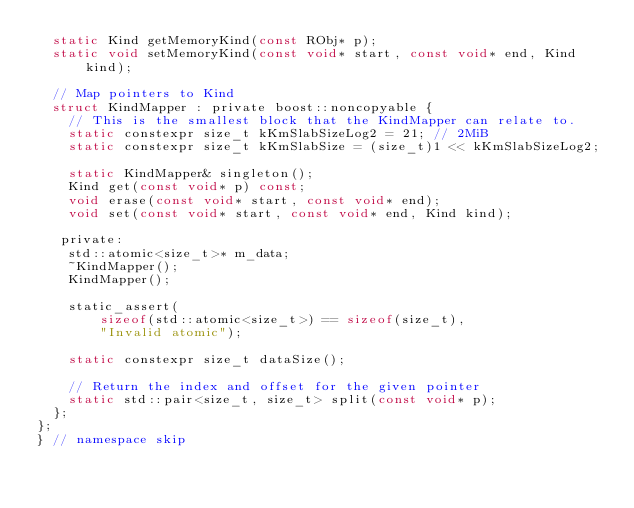Convert code to text. <code><loc_0><loc_0><loc_500><loc_500><_C_>  static Kind getMemoryKind(const RObj* p);
  static void setMemoryKind(const void* start, const void* end, Kind kind);

  // Map pointers to Kind
  struct KindMapper : private boost::noncopyable {
    // This is the smallest block that the KindMapper can relate to.
    static constexpr size_t kKmSlabSizeLog2 = 21; // 2MiB
    static constexpr size_t kKmSlabSize = (size_t)1 << kKmSlabSizeLog2;

    static KindMapper& singleton();
    Kind get(const void* p) const;
    void erase(const void* start, const void* end);
    void set(const void* start, const void* end, Kind kind);

   private:
    std::atomic<size_t>* m_data;
    ~KindMapper();
    KindMapper();

    static_assert(
        sizeof(std::atomic<size_t>) == sizeof(size_t),
        "Invalid atomic");

    static constexpr size_t dataSize();

    // Return the index and offset for the given pointer
    static std::pair<size_t, size_t> split(const void* p);
  };
};
} // namespace skip
</code> 